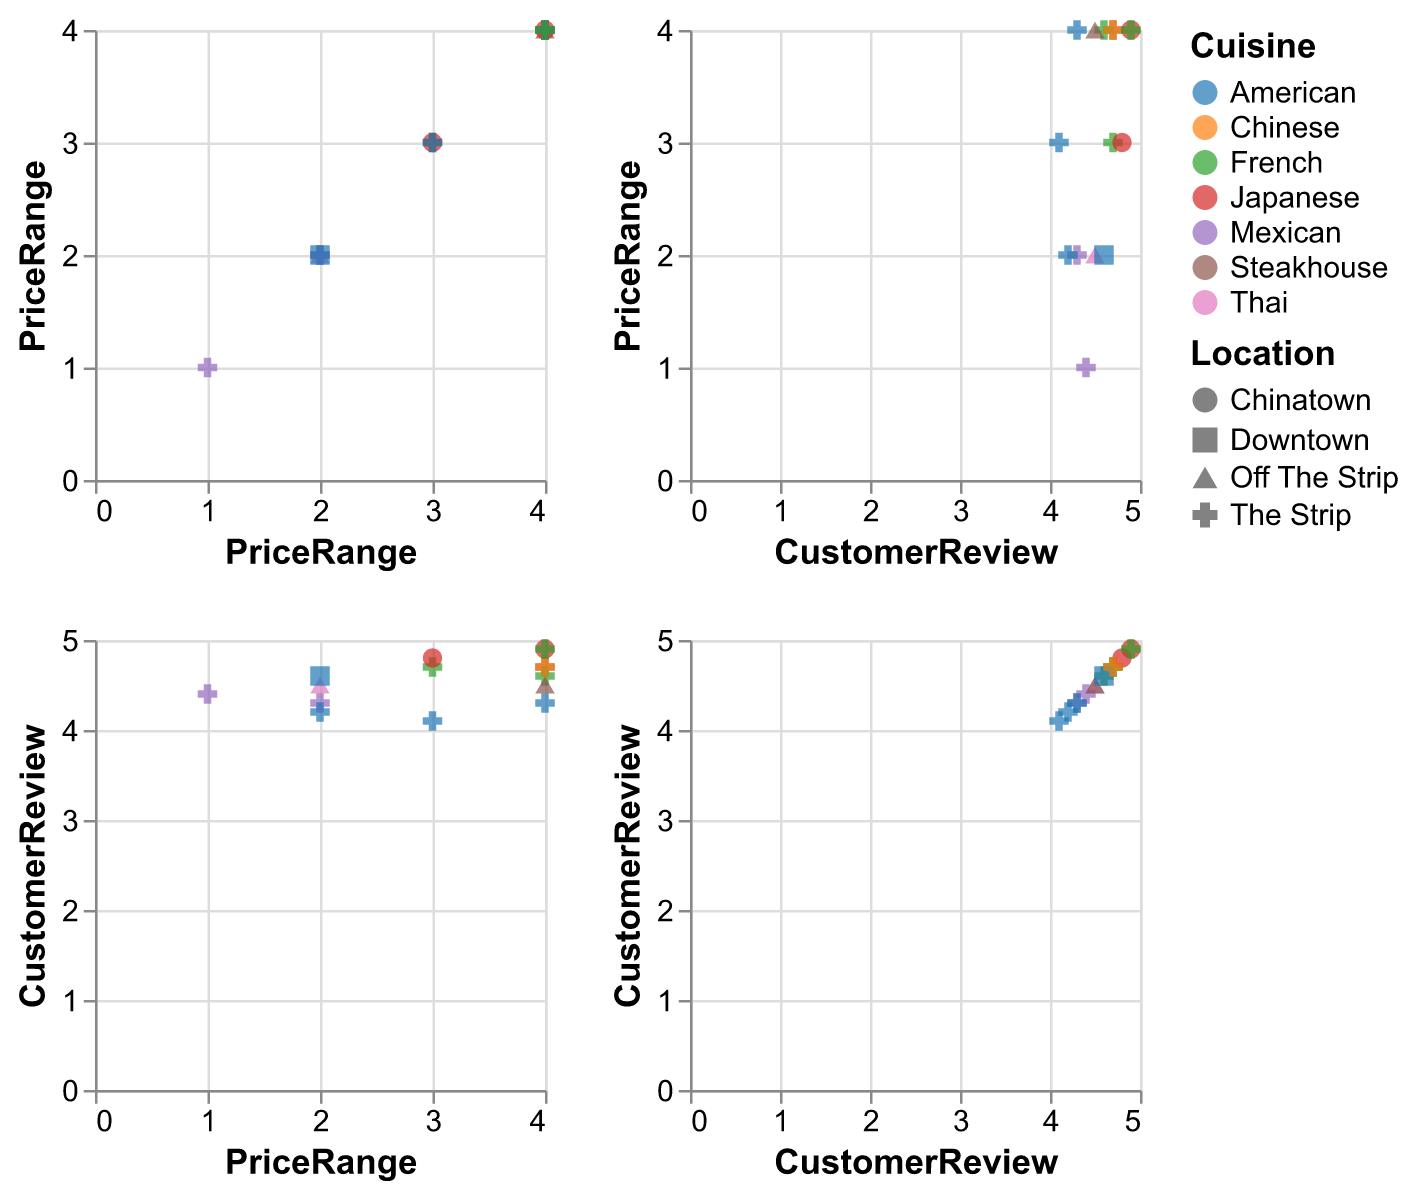What is the highest customer review rating for American cuisine? Look for the highest value on the CustomerReview axis among American cuisine data points. The highest rating for American cuisine is 4.6, which is from Carson Kitchen.
Answer: 4.6 How many restaurants have a price range of $$$$? Count the points with PriceRange at 4. There are 7 restaurants with a price range of $$$$.
Answer: 7 Is there a difference in the average customer review between restaurants located on The Strip and Downtown? Calculate the average customer review for both locations. For The Strip: (4.7 + 4.6 + 4.4 + 4.7 + 4.3 + 4.1 + 4.2 + 4.3 + 4.9)/9 = 4.48. For Downtown: Carson Kitchen’s review is 4.6. The difference is 4.48 - 4.6 = -0.12
Answer: -0.12 Which restaurant has the highest customer review, and what is its location and cuisine? Look for the highest point on the CustomerReview axis. The highest review is for Joel Robuchon, with a review of 4.9, located on The Strip and serves French cuisine.
Answer: Joel Robuchon, The Strip, French What is the price range for Kabuto, and how does its customer review compare to other Japanese restaurants? Kabuto has a price range of $$$$ and a customer review of 4.9. Compare this to Raku with a price range of $$$ and a customer review of 4.8. Kabuto has a higher review.
Answer: $$$$, higher Which cuisine type is represented by the most data points? Count the number of points for each cuisine type. American cuisine has 4 data points, which is the highest among all cuisine types.
Answer: American Are there more high-priced or low-priced French restaurants on The Strip? Filter French restaurants on The Strip; look at their price ranges. There are two high-priced (Eiffel Tower and Joel Robuchon) and one mid-priced (Le Cirque). Thus, more high-priced restaurants.
Answer: High-priced Do restaurants located in Chinatown have higher average customer reviews than those in Downtown? Calculate average reviews for Chinatown and Downtown. Chinatown (Raku and Kabuto): (4.8 + 4.9) / 2 = 4.85. Downtown: Carson Kitchen’s review is 4.6. ChinaTown has a higher average.
Answer: Yes What is the average Price Range for French cuisine restaurants? Sum the price ranges for French cuisine and divide by the number of restaurants. Price ranges: (4 + 4 + 3 + 4) = 15. Average = 15 / 4 = 3.75
Answer: 3.75 